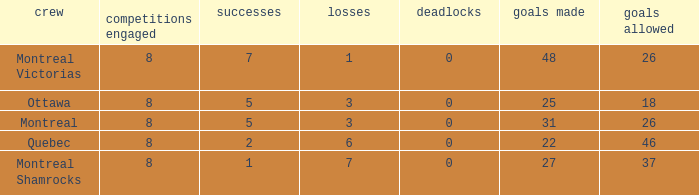For teams with fewer than 5 wins, goals against over 37, and fewer than 8 games played, what is the average number of ties? None. 